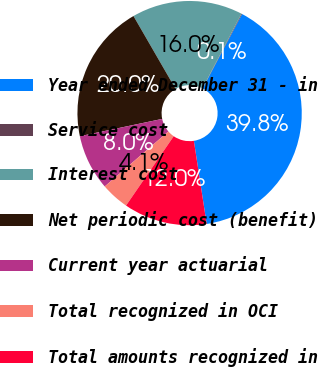Convert chart. <chart><loc_0><loc_0><loc_500><loc_500><pie_chart><fcel>Year ended December 31 - in<fcel>Service cost<fcel>Interest cost<fcel>Net periodic cost (benefit)<fcel>Current year actuarial<fcel>Total recognized in OCI<fcel>Total amounts recognized in<nl><fcel>39.82%<fcel>0.1%<fcel>15.99%<fcel>19.96%<fcel>8.04%<fcel>4.07%<fcel>12.02%<nl></chart> 